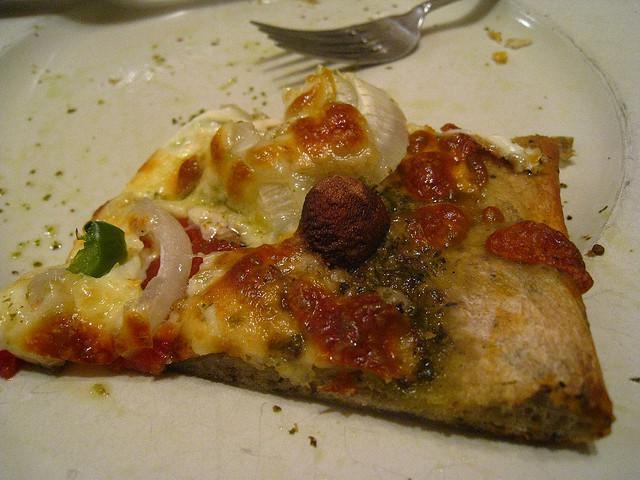How many plates are here?
Give a very brief answer. 1. How many people in the audience are wearing a yellow jacket?
Give a very brief answer. 0. 